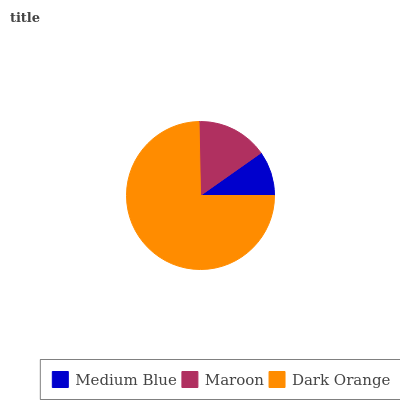Is Medium Blue the minimum?
Answer yes or no. Yes. Is Dark Orange the maximum?
Answer yes or no. Yes. Is Maroon the minimum?
Answer yes or no. No. Is Maroon the maximum?
Answer yes or no. No. Is Maroon greater than Medium Blue?
Answer yes or no. Yes. Is Medium Blue less than Maroon?
Answer yes or no. Yes. Is Medium Blue greater than Maroon?
Answer yes or no. No. Is Maroon less than Medium Blue?
Answer yes or no. No. Is Maroon the high median?
Answer yes or no. Yes. Is Maroon the low median?
Answer yes or no. Yes. Is Medium Blue the high median?
Answer yes or no. No. Is Dark Orange the low median?
Answer yes or no. No. 